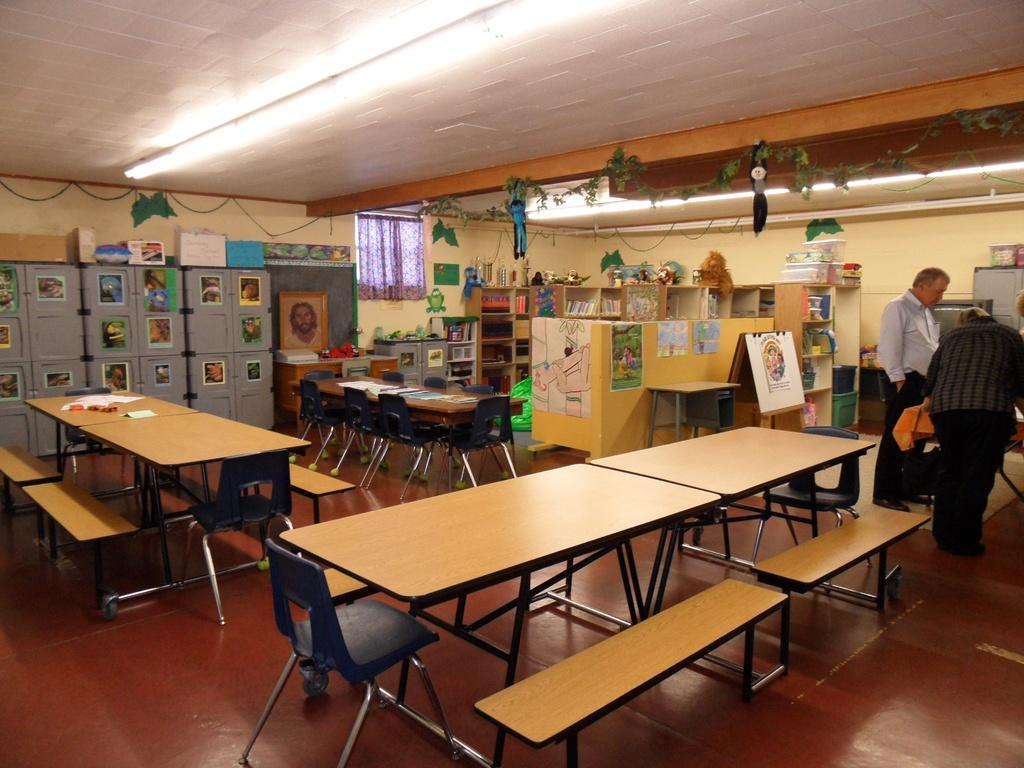How many people are in the image? There are two people standing in the right corner of the image. What type of furniture is present in the image? There are tables and benches in the image. Are the tables and benches occupied in the image? No, the tables and benches are left empty in the image. What type of advertisement can be seen on the benches in the image? There is no advertisement present on the benches in the image. What type of bun is being served on the tables in the image? There are no buns or food items present on the tables in the image. 